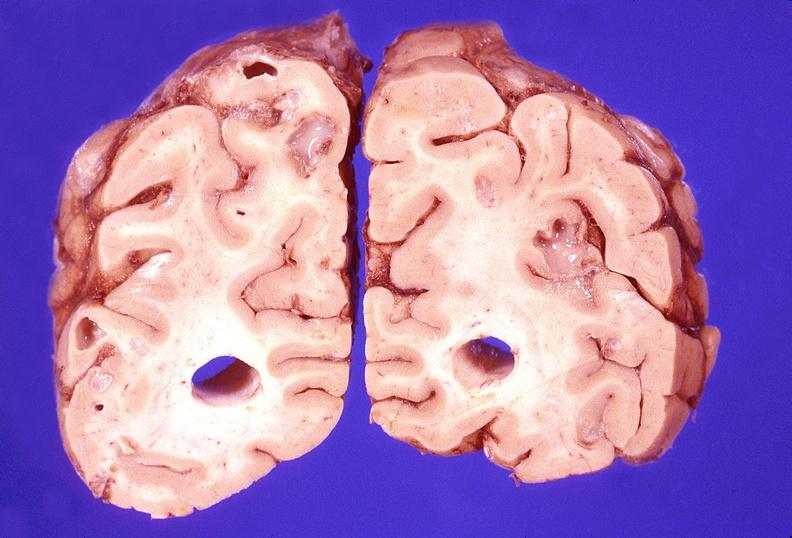s nervous present?
Answer the question using a single word or phrase. Yes 